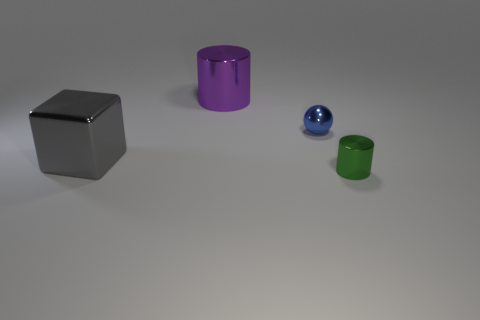Add 3 large purple objects. How many objects exist? 7 Subtract all spheres. How many objects are left? 3 Add 3 small green cylinders. How many small green cylinders exist? 4 Subtract 0 purple cubes. How many objects are left? 4 Subtract all gray matte cylinders. Subtract all small blue shiny balls. How many objects are left? 3 Add 4 large purple metal things. How many large purple metal things are left? 5 